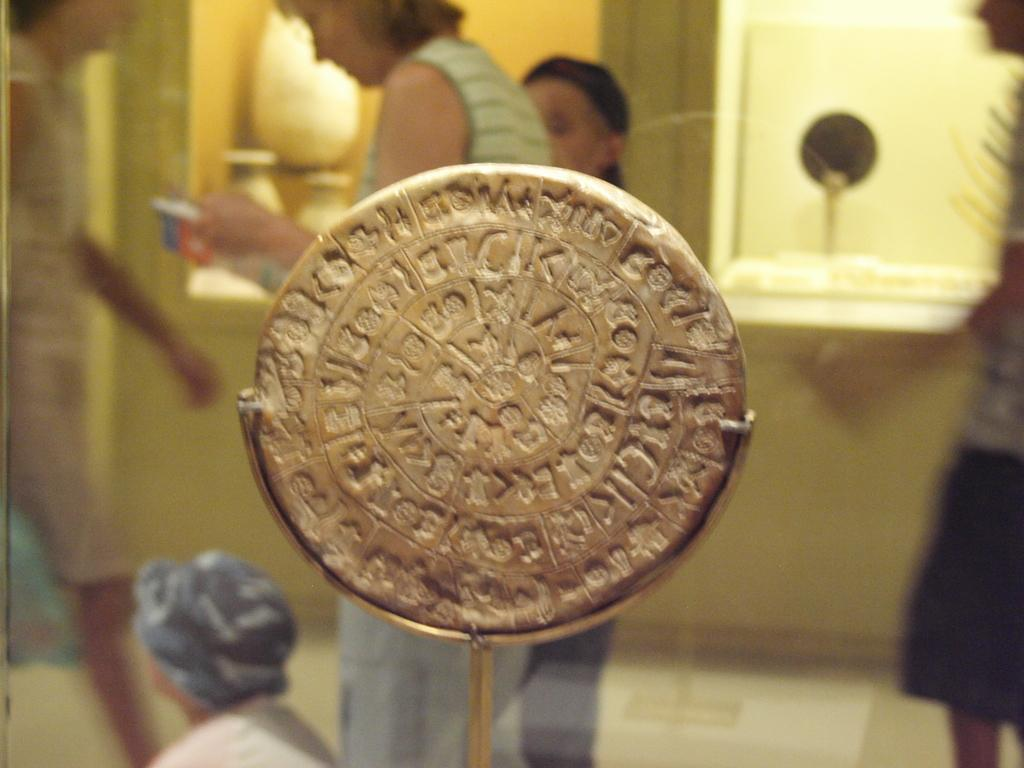What type of object is made of metal in the image? There is a metal object in the image, but the specific type cannot be determined from the provided facts. Can you describe the people in the image? The provided facts only mention that there are people standing in the image, but their appearance, clothing, or actions cannot be determined. What can be seen in the background of the image? There is a window visible in the background of the image. What type of toys are being exchanged between family members in the image? There is no mention of toys or family members in the image, so this question cannot be answered definitively. 